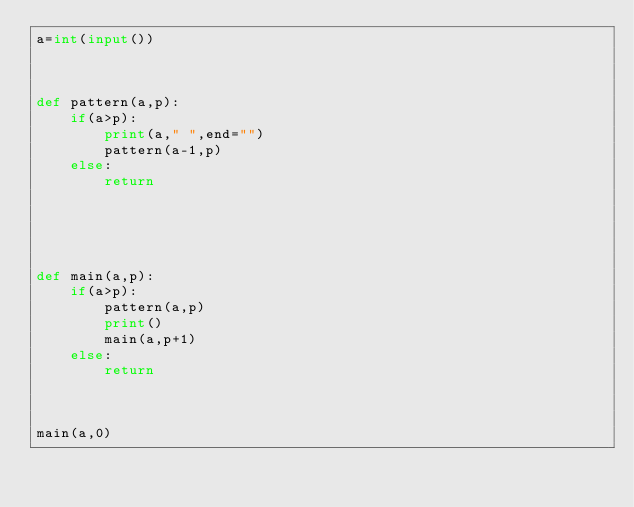<code> <loc_0><loc_0><loc_500><loc_500><_Python_>a=int(input())



def pattern(a,p):
    if(a>p):
        print(a," ",end="")
        pattern(a-1,p)
    else:
        return
    




def main(a,p):
    if(a>p):
        pattern(a,p)
        print()
        main(a,p+1)
    else:
        return
    


main(a,0)
                              
</code> 